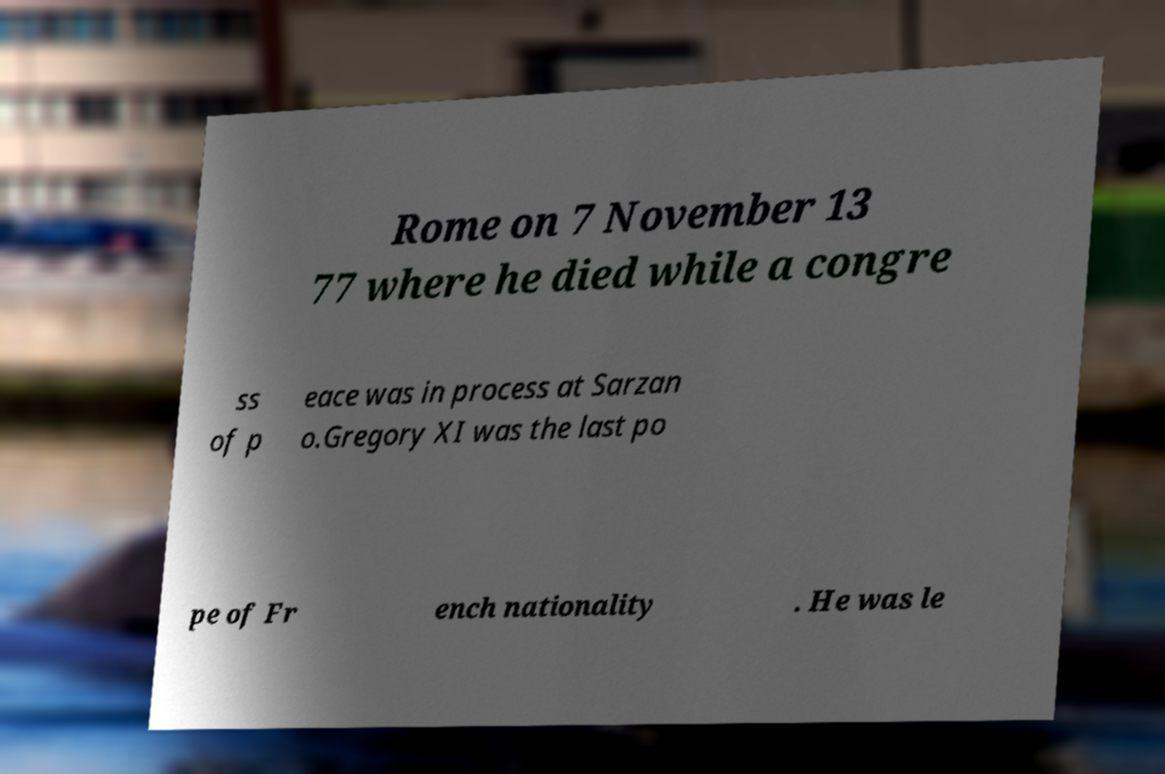Can you explain what the 'congress of peace' mentioned in the text might refer to and its context during the time of Gregory XI? The 'congress of peace' mentioned in the text likely refers to efforts or meetings aimed at resolving conflicts or promoting peace during Gregory XI's papacy. The late 14th century was a period marked by various political and military tensions in Europe, including the Hundred Years' War. A congress of peace in this context would have been an attempt to mediate and resolve disputes that were impacting the region, particularly those affecting the Church's interests and the stability of Christian states. Was there a significant impact from such peace efforts? While specific impacts of such congresses can vary, they generally aimed to reduce warfare and promote diplomacy. Although the long-term effectiveness of these particular 14th-century peace efforts may have been limited due to the era's ongoing conflicts, they were important in setting precedents for diplomatic conflict resolution and demonstrated the Church's role in international politics beyond religious matters. 